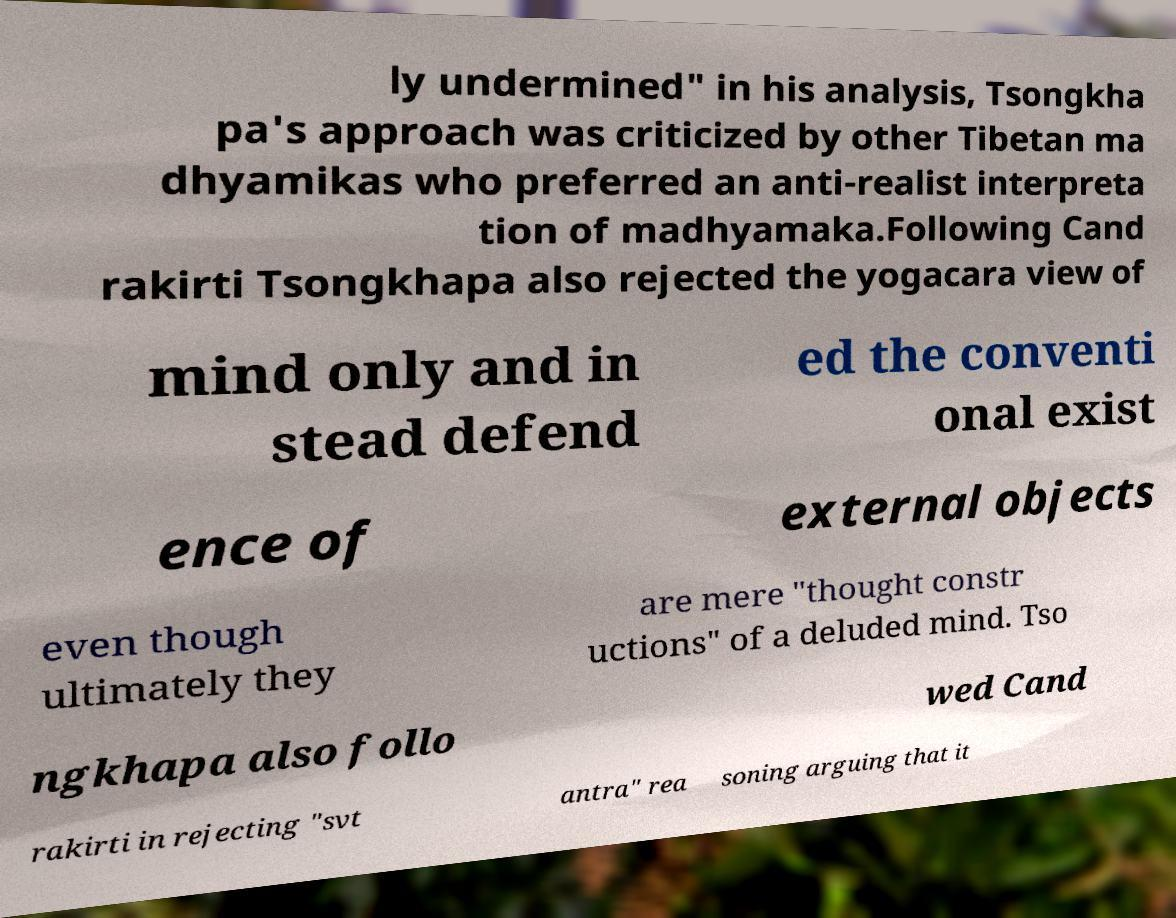Could you extract and type out the text from this image? ly undermined" in his analysis, Tsongkha pa's approach was criticized by other Tibetan ma dhyamikas who preferred an anti-realist interpreta tion of madhyamaka.Following Cand rakirti Tsongkhapa also rejected the yogacara view of mind only and in stead defend ed the conventi onal exist ence of external objects even though ultimately they are mere "thought constr uctions" of a deluded mind. Tso ngkhapa also follo wed Cand rakirti in rejecting "svt antra" rea soning arguing that it 